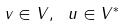Convert formula to latex. <formula><loc_0><loc_0><loc_500><loc_500>v \in V , \ u \in V ^ { * }</formula> 